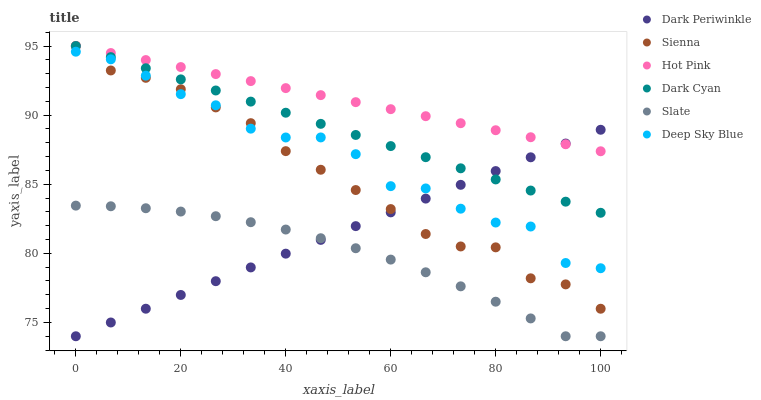Does Slate have the minimum area under the curve?
Answer yes or no. Yes. Does Hot Pink have the maximum area under the curve?
Answer yes or no. Yes. Does Sienna have the minimum area under the curve?
Answer yes or no. No. Does Sienna have the maximum area under the curve?
Answer yes or no. No. Is Dark Periwinkle the smoothest?
Answer yes or no. Yes. Is Deep Sky Blue the roughest?
Answer yes or no. Yes. Is Hot Pink the smoothest?
Answer yes or no. No. Is Hot Pink the roughest?
Answer yes or no. No. Does Slate have the lowest value?
Answer yes or no. Yes. Does Sienna have the lowest value?
Answer yes or no. No. Does Dark Cyan have the highest value?
Answer yes or no. Yes. Does Deep Sky Blue have the highest value?
Answer yes or no. No. Is Slate less than Hot Pink?
Answer yes or no. Yes. Is Dark Cyan greater than Deep Sky Blue?
Answer yes or no. Yes. Does Dark Periwinkle intersect Slate?
Answer yes or no. Yes. Is Dark Periwinkle less than Slate?
Answer yes or no. No. Is Dark Periwinkle greater than Slate?
Answer yes or no. No. Does Slate intersect Hot Pink?
Answer yes or no. No. 